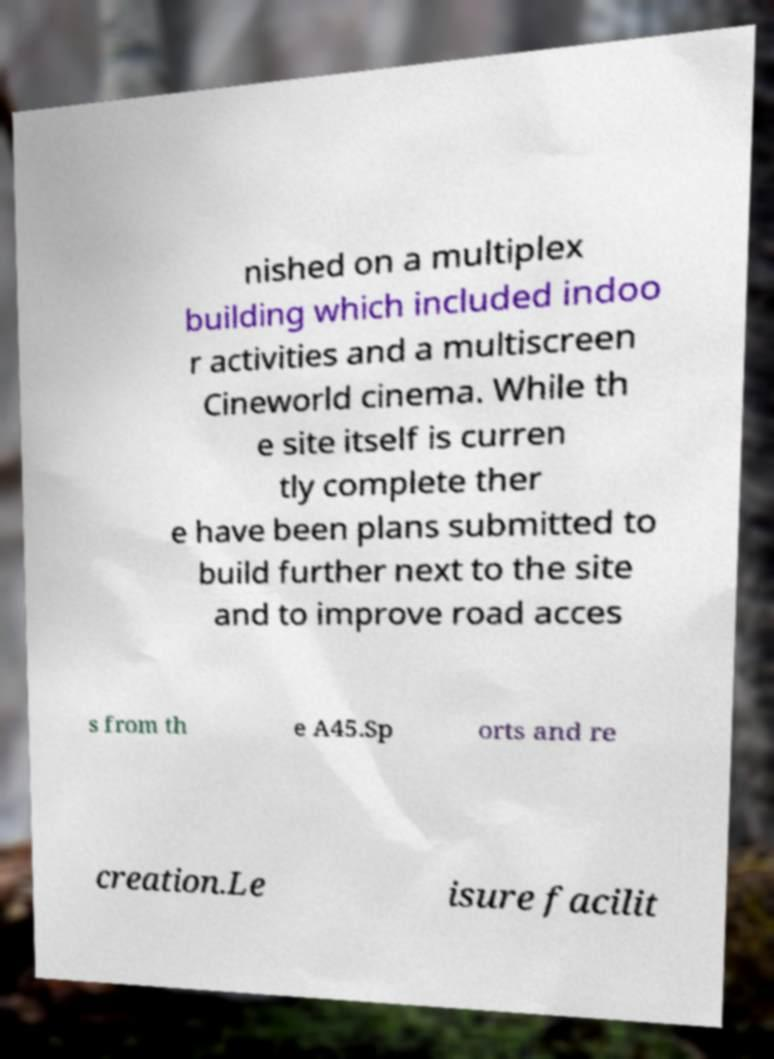For documentation purposes, I need the text within this image transcribed. Could you provide that? nished on a multiplex building which included indoo r activities and a multiscreen Cineworld cinema. While th e site itself is curren tly complete ther e have been plans submitted to build further next to the site and to improve road acces s from th e A45.Sp orts and re creation.Le isure facilit 